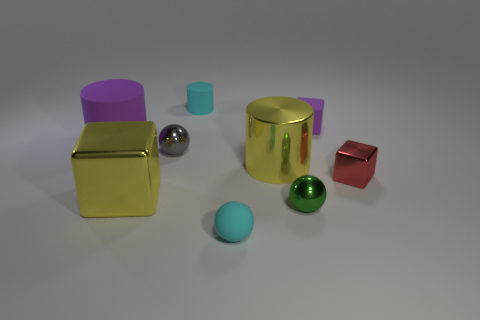There is a tiny cyan object that is the same shape as the small green object; what is it made of?
Your answer should be compact. Rubber. Are there an equal number of metal things that are in front of the small cyan ball and small matte things in front of the tiny cylinder?
Ensure brevity in your answer.  No. What size is the shiny cube in front of the red cube?
Your response must be concise. Large. Are there any tiny purple things made of the same material as the tiny cylinder?
Make the answer very short. Yes. There is a large cylinder on the left side of the yellow cylinder; does it have the same color as the small rubber block?
Offer a terse response. Yes. Are there an equal number of shiny balls that are in front of the tiny red shiny cube and big brown matte cylinders?
Offer a terse response. No. Is there a big matte cylinder of the same color as the metal cylinder?
Make the answer very short. No. Does the yellow cube have the same size as the cyan rubber cylinder?
Your answer should be very brief. No. What is the size of the cyan object on the left side of the small ball that is in front of the tiny green thing?
Provide a succinct answer. Small. There is a matte object that is in front of the tiny purple thing and behind the tiny green metal object; how big is it?
Give a very brief answer. Large. 